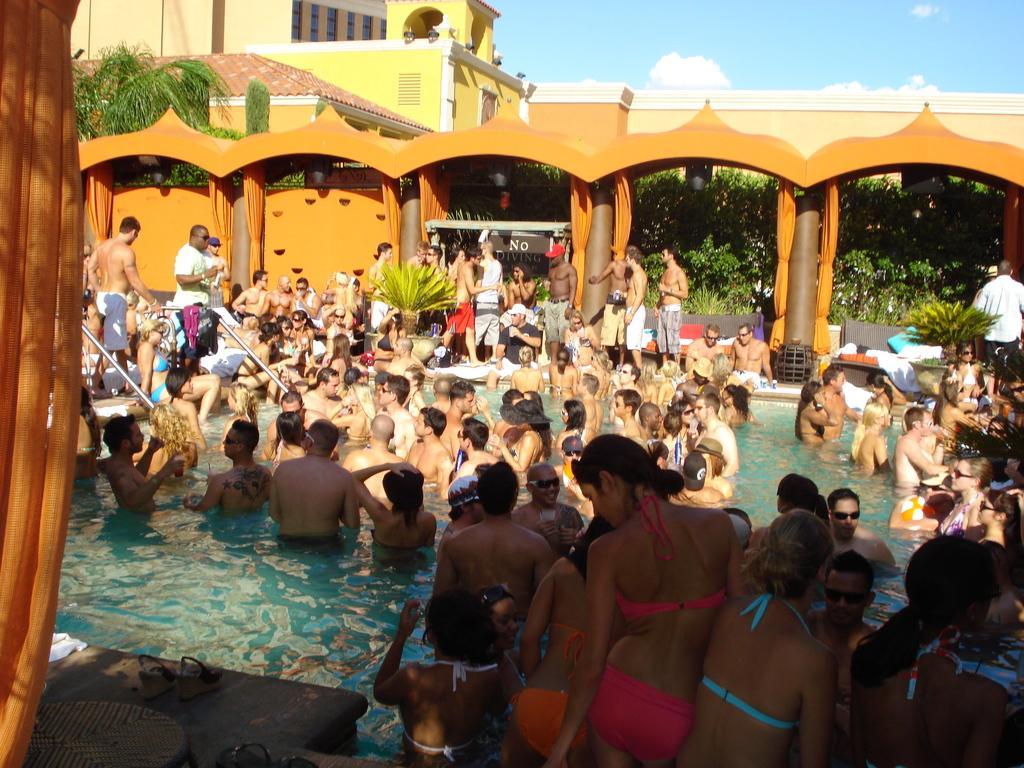Describe this image in one or two sentences. An outside picture. In-front there is a swimming pool. In a swimming pool the number of people are standing. Sky is in blue color. In-front there is a building with windows. Pillars are in brown color. Beside this pillar there is a orange curtain. Sandals. Far there are number of trees. The wall is in orange color. Number of plants, backside of this pillars. 